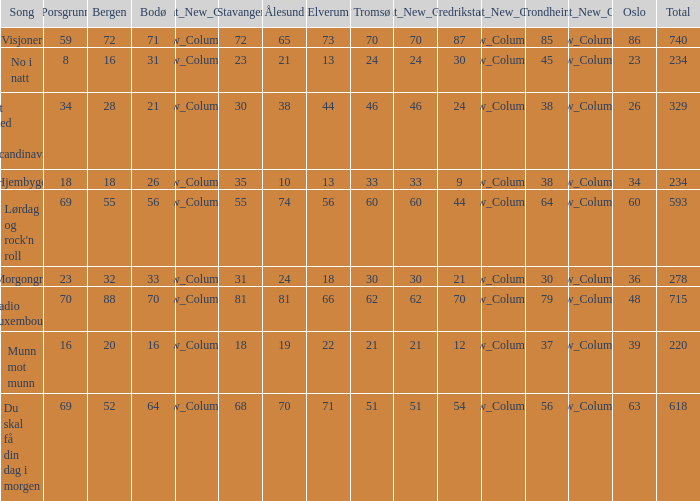What was the total for radio luxembourg? 715.0. 